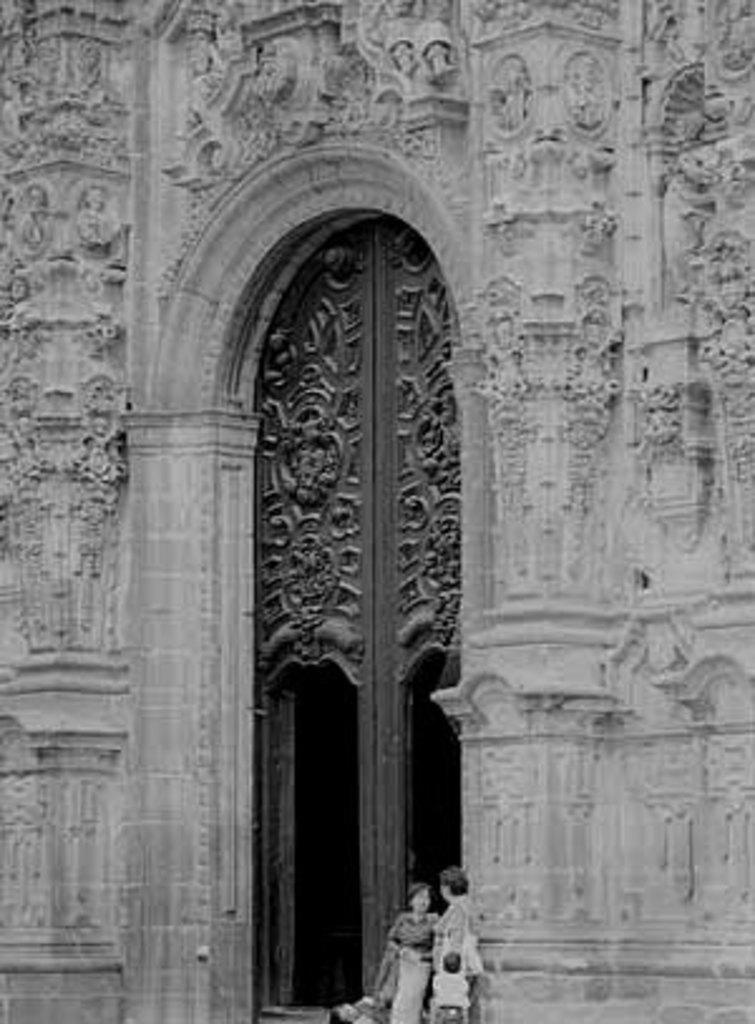Can you describe this image briefly? In this picture we can see a building, there are two persons standing at the bottom, we can see a door in the middle, it is a black and white image. 